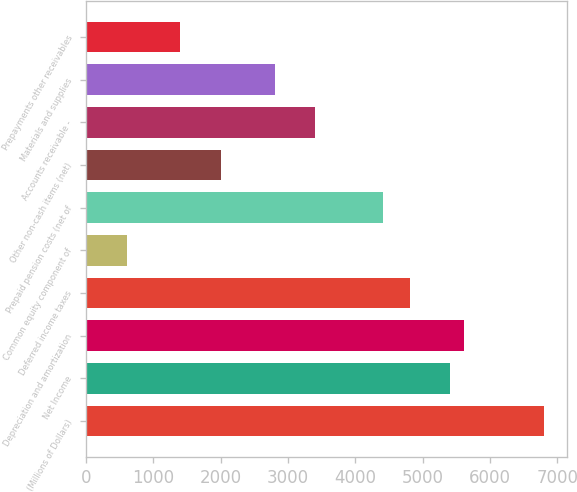Convert chart to OTSL. <chart><loc_0><loc_0><loc_500><loc_500><bar_chart><fcel>(Millions of Dollars)<fcel>Net Income<fcel>Depreciation and amortization<fcel>Deferred income taxes<fcel>Common equity component of<fcel>Prepaid pension costs (net of<fcel>Other non-cash items (net)<fcel>Accounts receivable -<fcel>Materials and supplies<fcel>Prepayments other receivables<nl><fcel>6807.8<fcel>5406.4<fcel>5606.6<fcel>4805.8<fcel>601.6<fcel>4405.4<fcel>2003<fcel>3404.4<fcel>2803.8<fcel>1402.4<nl></chart> 